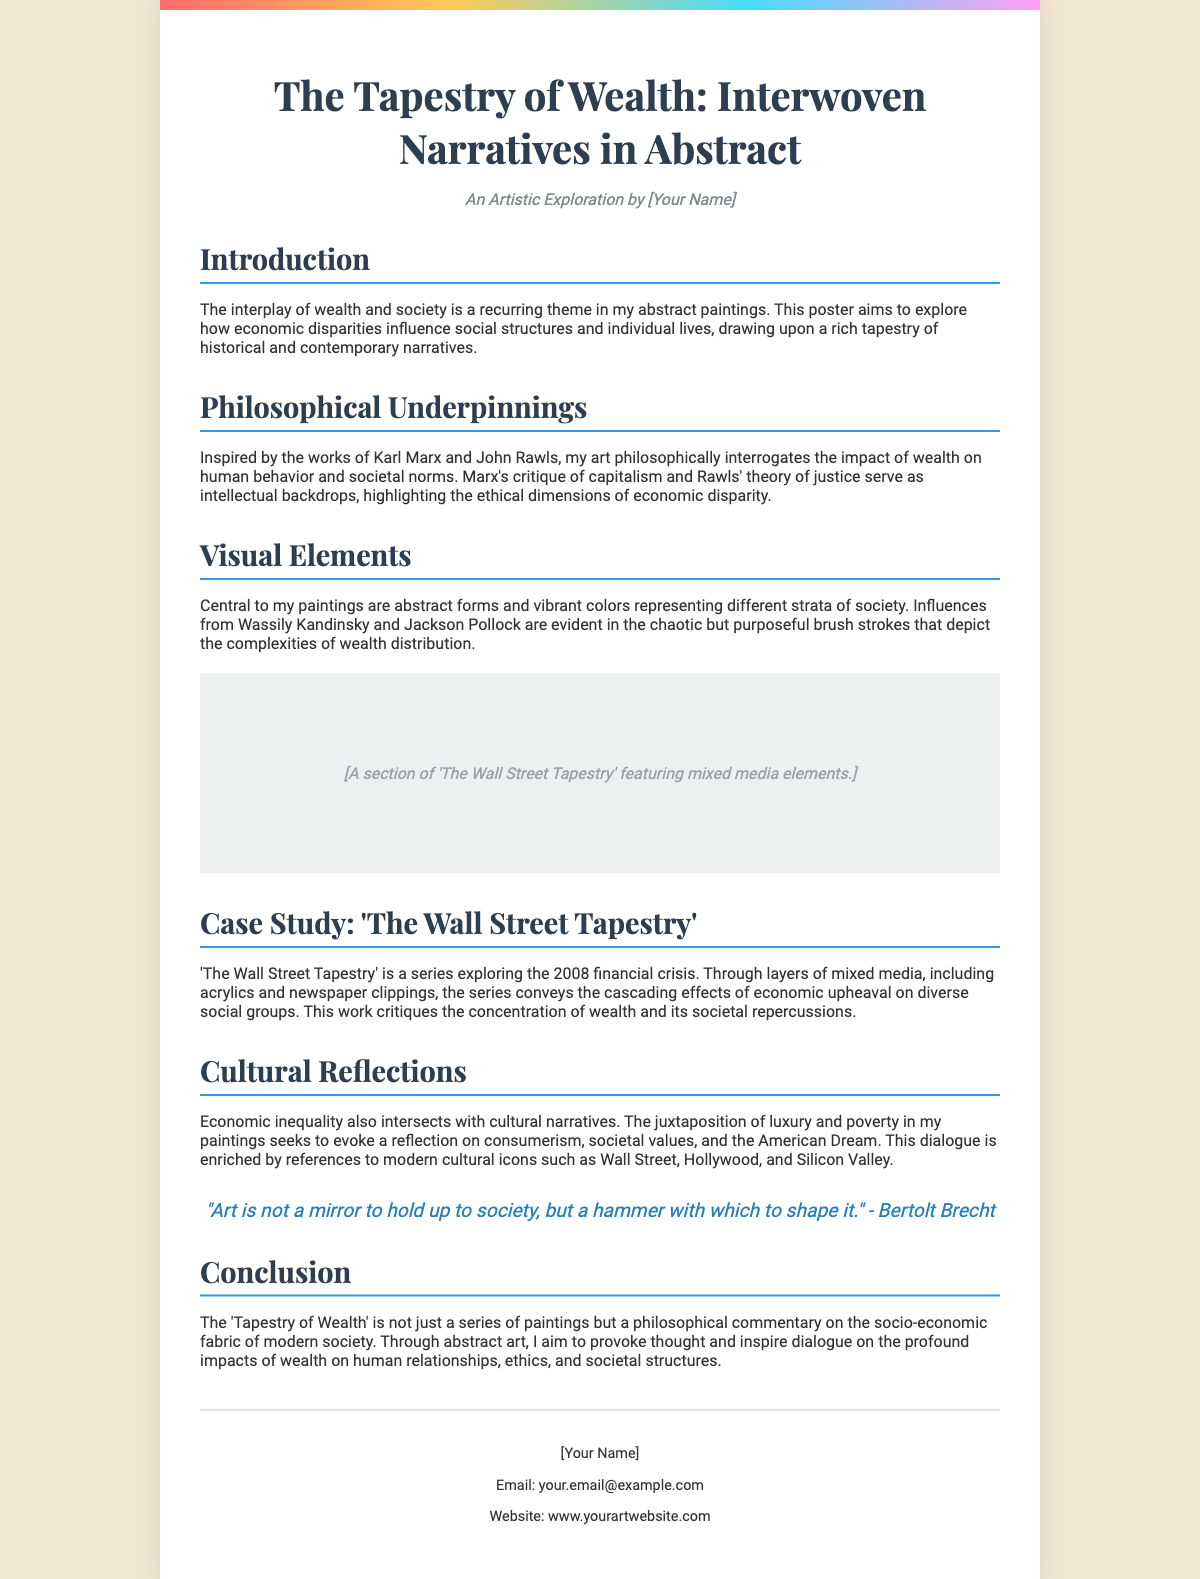What is the title of the poster? The title is explicitly stated in the heading of the document.
Answer: The Tapestry of Wealth: Interwoven Narratives in Abstract Who is the author of the poster? The author is mentioned in the subtitle section of the document.
Answer: [Your Name] What artistic influences are referenced? The influences are detailed in the Visual Elements section, where specific artists are named.
Answer: Wassily Kandinsky and Jackson Pollock What year does the case study 'The Wall Street Tapestry' relate to? The document specifies the financial crisis related to this case study.
Answer: 2008 What philosophical thinker is mentioned alongside Karl Marx? The mention occurs in the Philosophical Underpinnings section, where another thinker's theory is highlighted.
Answer: John Rawls What type of media is used in 'The Wall Street Tapestry'? The document lists materials employed in the case study in the respective section.
Answer: Acrylics and newspaper clippings How does the author define the role of art according to Bertolt Brecht? The author includes a quote that exemplifies this viewpoint in the quote section.
Answer: A hammer with which to shape it What is the main theme of the poster? The introduction summarizes the core focus of the document.
Answer: The interplay of wealth and society 